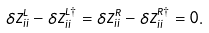<formula> <loc_0><loc_0><loc_500><loc_500>\delta Z _ { i i } ^ { L } - \delta Z _ { i i } ^ { L \dagger } = \delta Z _ { i i } ^ { R } - \delta Z _ { i i } ^ { R \dagger } = 0 .</formula> 